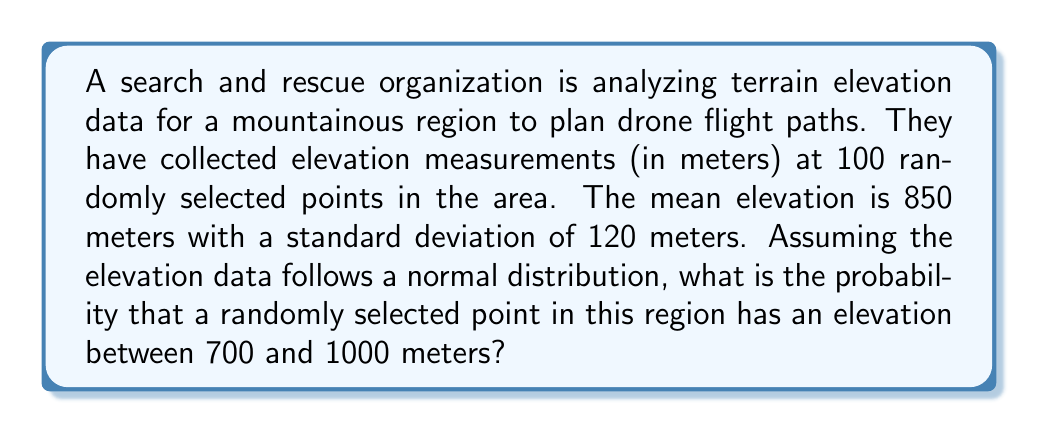Provide a solution to this math problem. To solve this problem, we need to use the properties of the normal distribution and the concept of z-scores.

Given:
- Mean elevation (μ) = 850 meters
- Standard deviation (σ) = 120 meters
- We want to find P(700 < X < 1000), where X is the elevation of a randomly selected point

Step 1: Calculate the z-scores for the lower and upper bounds.
For the lower bound (700 meters):
$z_1 = \frac{x - \mu}{\sigma} = \frac{700 - 850}{120} = -1.25$

For the upper bound (1000 meters):
$z_2 = \frac{x - \mu}{\sigma} = \frac{1000 - 850}{120} = 1.25$

Step 2: Use the standard normal distribution table or a calculator to find the area under the curve between these z-scores.

The probability is equal to the area between z = -1.25 and z = 1.25 under the standard normal curve.

P(700 < X < 1000) = P(-1.25 < Z < 1.25)

Using a standard normal distribution table or calculator:
P(Z < 1.25) ≈ 0.8944
P(Z < -1.25) ≈ 0.1056

The probability we're looking for is the difference between these two values:
P(-1.25 < Z < 1.25) = 0.8944 - 0.1056 = 0.7888

Step 3: Convert the probability to a percentage.
0.7888 * 100% = 78.88%

Therefore, the probability that a randomly selected point in this region has an elevation between 700 and 1000 meters is approximately 78.88%.
Answer: The probability is approximately 78.88%. 